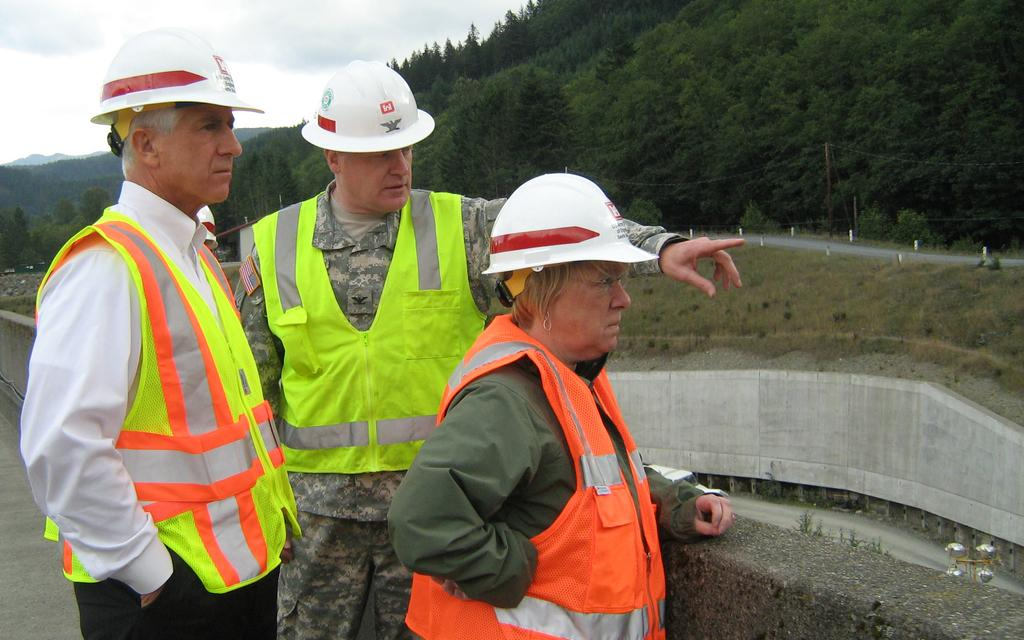How many people are in the image? There are three persons standing in the image. What are the persons wearing on their heads? The persons are wearing helmets. What type of vegetation can be seen in the image? There are trees, plants, and grass visible in the image. What structures can be seen in the image? There are poles in the image. What is the natural landscape visible in the image? There are mountains in the image. What is visible in the background of the image? The sky is visible in the background of the image, with clouds. What type of rice is being cooked in the image? There is no rice present in the image; it features three persons wearing helmets, trees, plants, grass, poles, mountains, and a sky with clouds. What test is being conducted by the persons in the image? There is no indication of a test being conducted in the image; the persons are simply standing and wearing helmets. 